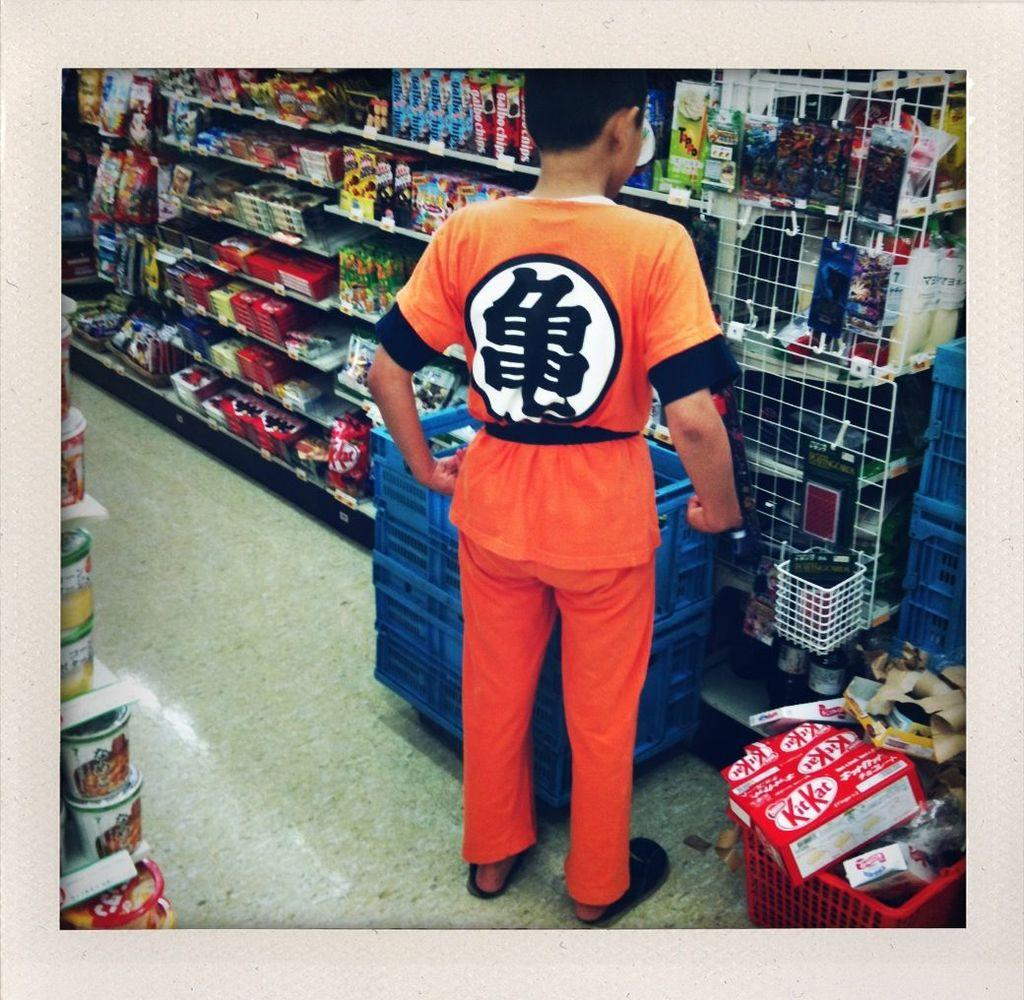What is the main subject of the image? There is a person standing in the image. Where is the person standing? The person is standing on the floor. What other objects can be seen in the image? There are baskets in the image. What can be seen in the background of the image? There are objects in racks in the background of the image. What type of farm animals can be seen in the image? There are no farm animals present in the image. What force is being applied to the person standing in the image? There is no force being applied to the person standing in the image; they are standing on their own. 